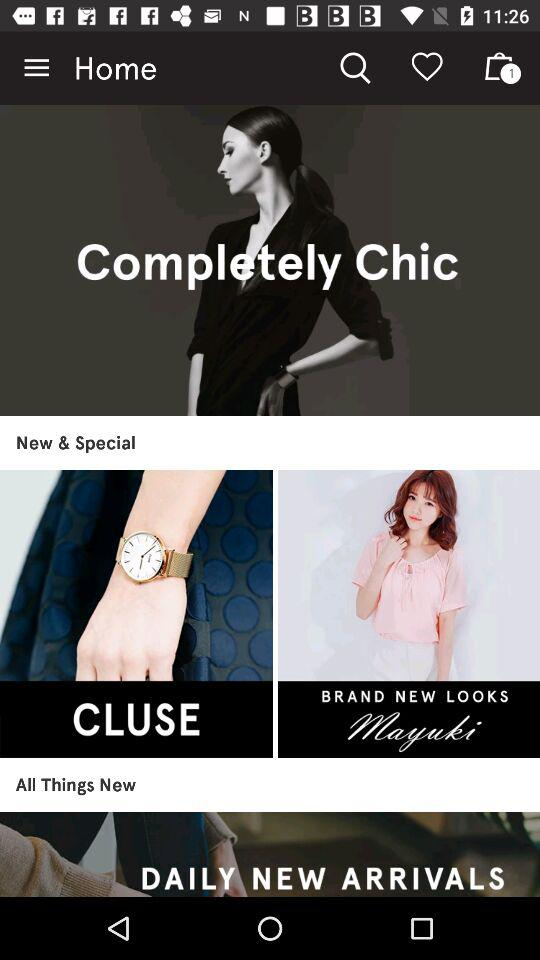How many items are there in the cart? There is 1 item in the cart. 